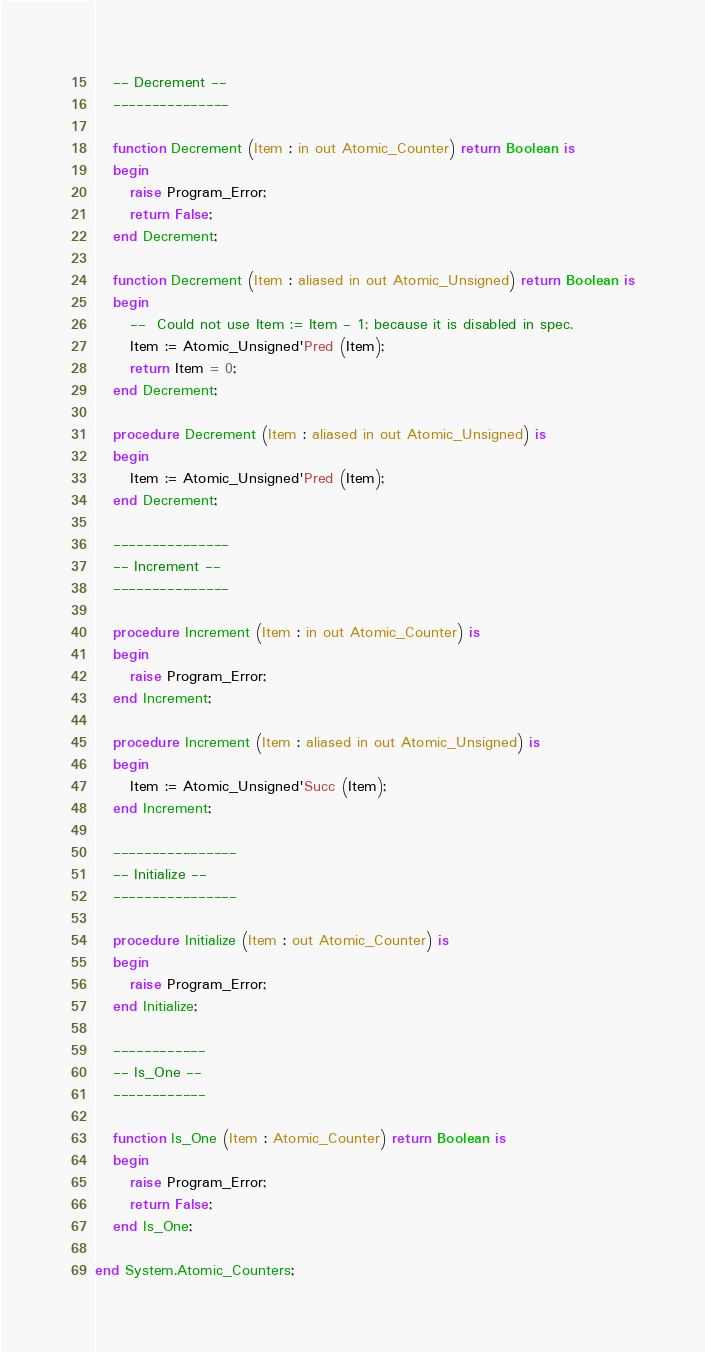<code> <loc_0><loc_0><loc_500><loc_500><_Ada_>   -- Decrement --
   ---------------

   function Decrement (Item : in out Atomic_Counter) return Boolean is
   begin
      raise Program_Error;
      return False;
   end Decrement;

   function Decrement (Item : aliased in out Atomic_Unsigned) return Boolean is
   begin
      --  Could not use Item := Item - 1; because it is disabled in spec.
      Item := Atomic_Unsigned'Pred (Item);
      return Item = 0;
   end Decrement;

   procedure Decrement (Item : aliased in out Atomic_Unsigned) is
   begin
      Item := Atomic_Unsigned'Pred (Item);
   end Decrement;

   ---------------
   -- Increment --
   ---------------

   procedure Increment (Item : in out Atomic_Counter) is
   begin
      raise Program_Error;
   end Increment;

   procedure Increment (Item : aliased in out Atomic_Unsigned) is
   begin
      Item := Atomic_Unsigned'Succ (Item);
   end Increment;

   ----------------
   -- Initialize --
   ----------------

   procedure Initialize (Item : out Atomic_Counter) is
   begin
      raise Program_Error;
   end Initialize;

   ------------
   -- Is_One --
   ------------

   function Is_One (Item : Atomic_Counter) return Boolean is
   begin
      raise Program_Error;
      return False;
   end Is_One;

end System.Atomic_Counters;
</code> 